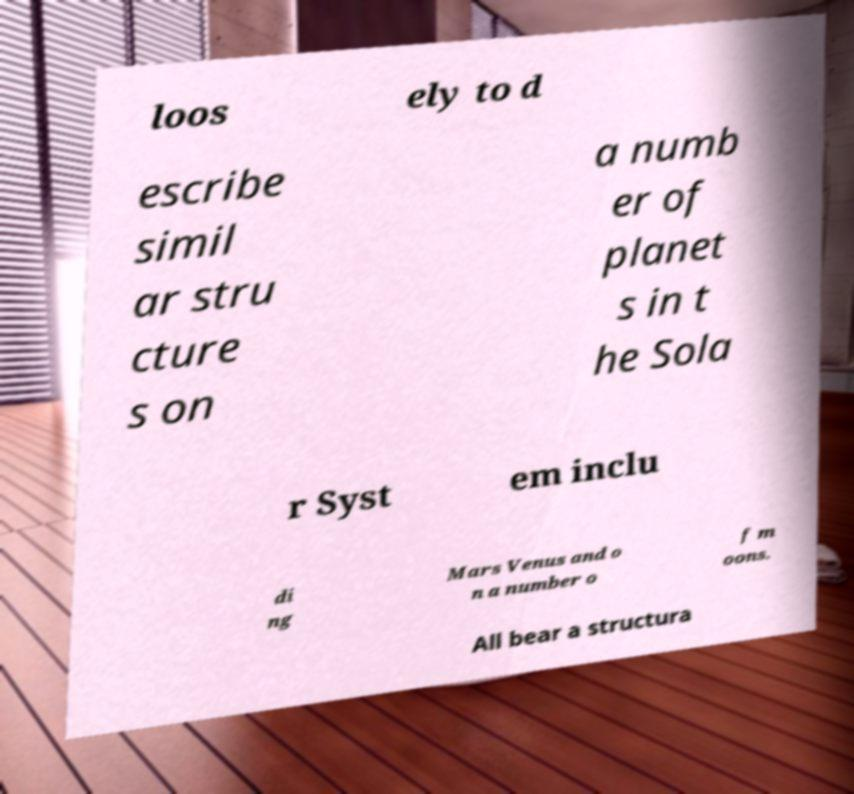Could you assist in decoding the text presented in this image and type it out clearly? loos ely to d escribe simil ar stru cture s on a numb er of planet s in t he Sola r Syst em inclu di ng Mars Venus and o n a number o f m oons. All bear a structura 